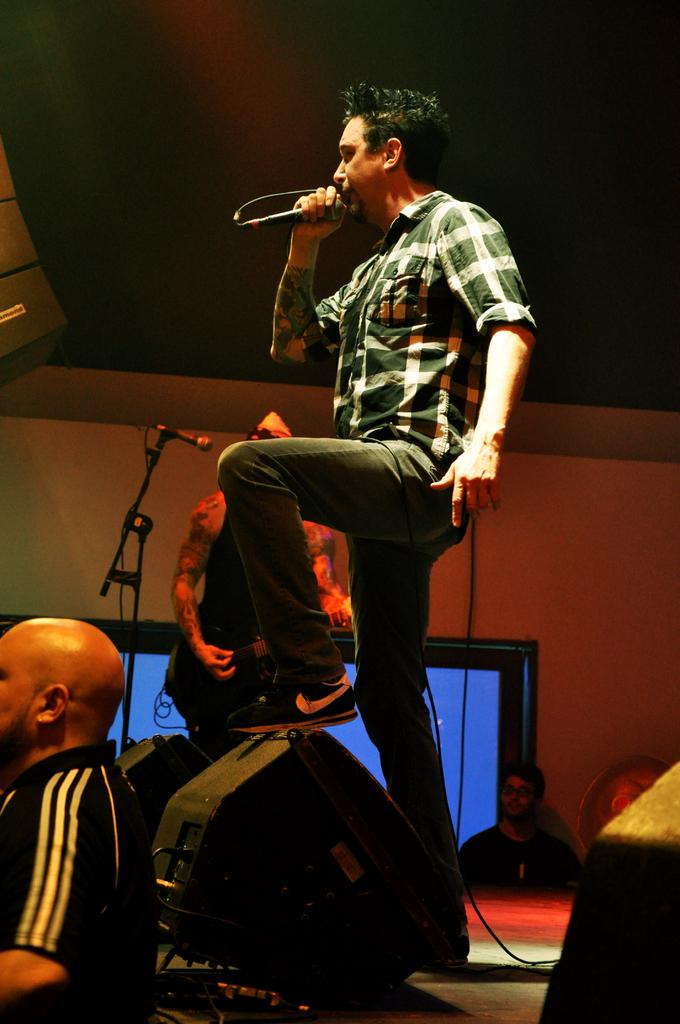What is the main subject of the image? The main subject of the image is a person standing on the stage. What is the person on stage holding? The person on stage is holding a microphone. What is the person on stage doing? The person on stage is singing. Can you describe the other person in the image? There is another person standing at the left side of the image, and they are on the floor. What type of pets can be seen in the image? There are no pets visible in the image. Is there a tent set up in the background of the image? There is no tent present in the image. 